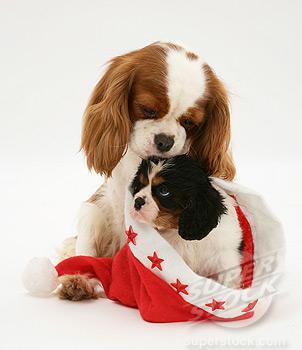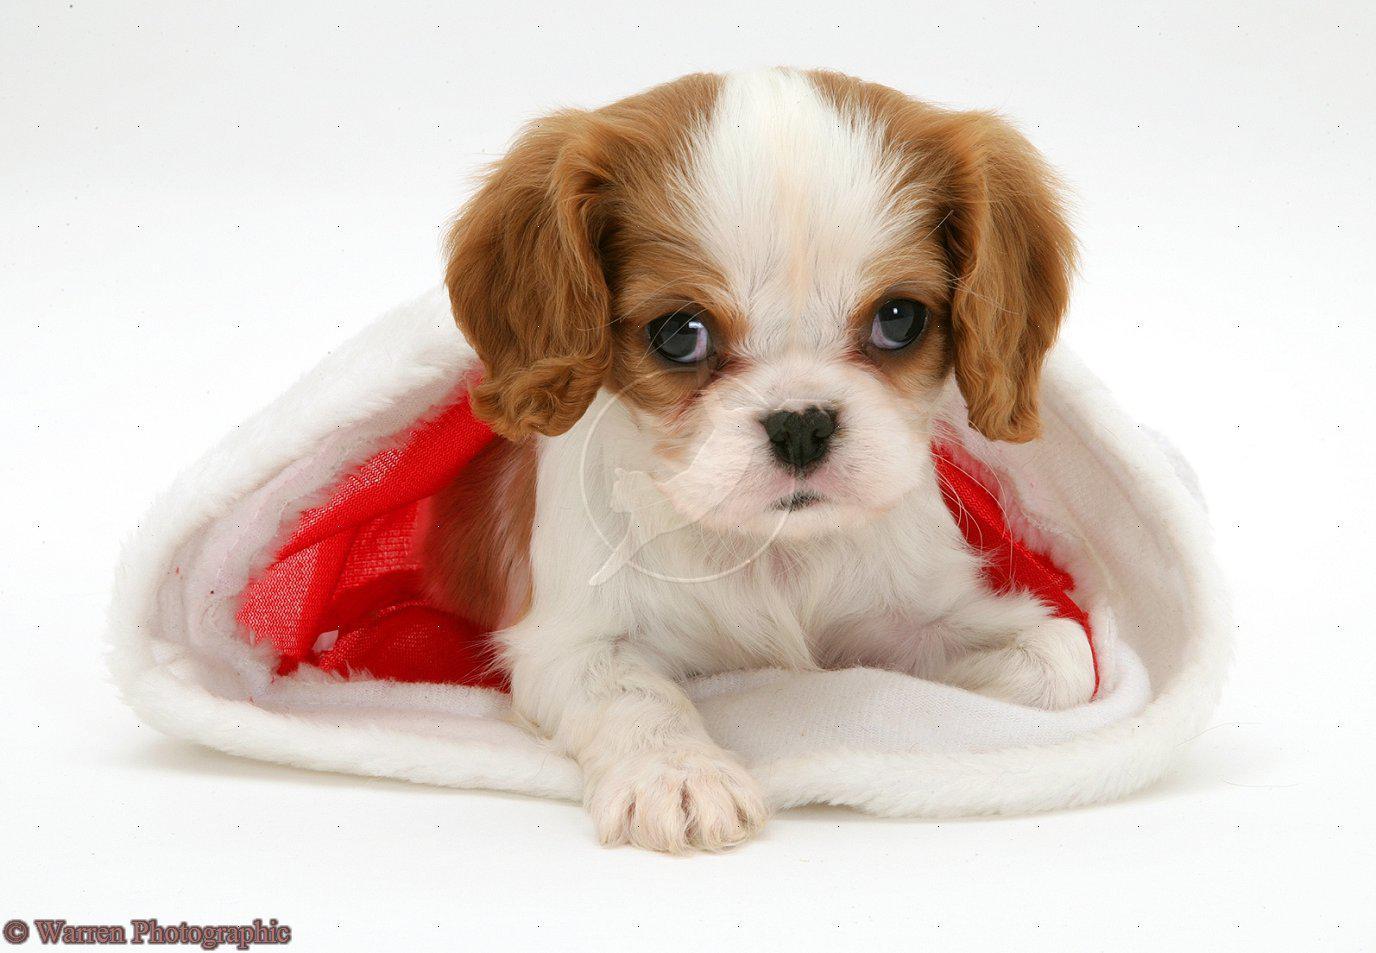The first image is the image on the left, the second image is the image on the right. Examine the images to the left and right. Is the description "The left image shows a black, white and brown dog inside a santa hat and a brown and white dog next to it" accurate? Answer yes or no. Yes. The first image is the image on the left, the second image is the image on the right. Evaluate the accuracy of this statement regarding the images: "An image shows one puppy in a Santa hat and another puppy behind the hat.". Is it true? Answer yes or no. Yes. 